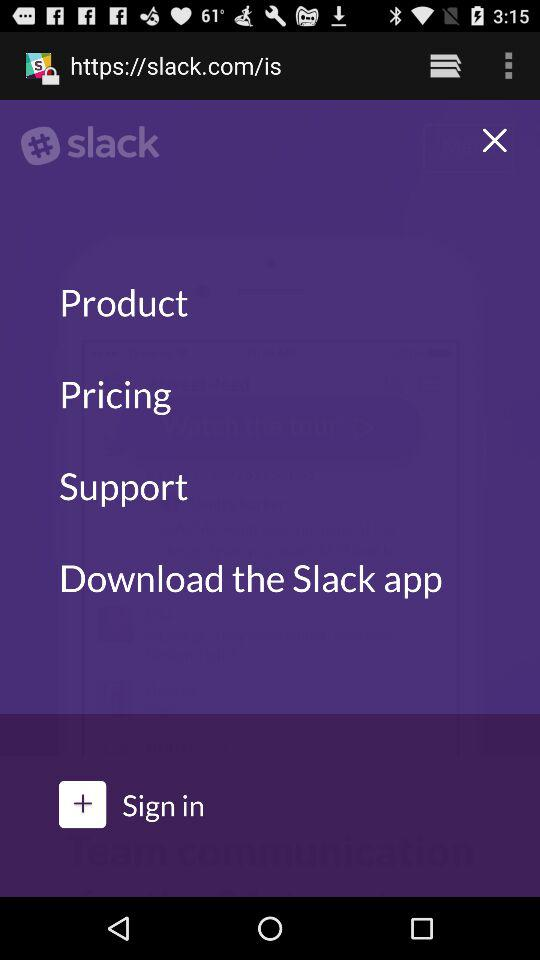What is the application name? The application name is "slack". 